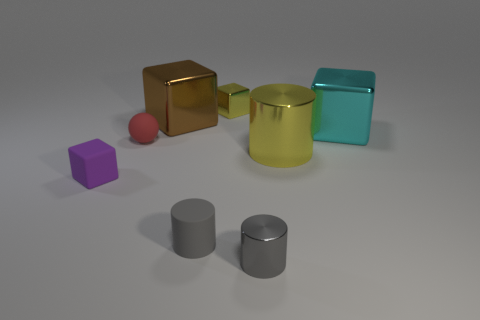Add 1 gray metal things. How many objects exist? 9 Subtract all gray cylinders. How many cylinders are left? 1 Subtract all metal blocks. How many blocks are left? 1 Subtract 0 cyan cylinders. How many objects are left? 8 Subtract all cylinders. How many objects are left? 5 Subtract 1 spheres. How many spheres are left? 0 Subtract all brown cylinders. Subtract all yellow cubes. How many cylinders are left? 3 Subtract all cyan spheres. How many cyan blocks are left? 1 Subtract all small yellow metal objects. Subtract all large brown metallic cubes. How many objects are left? 6 Add 1 tiny objects. How many tiny objects are left? 6 